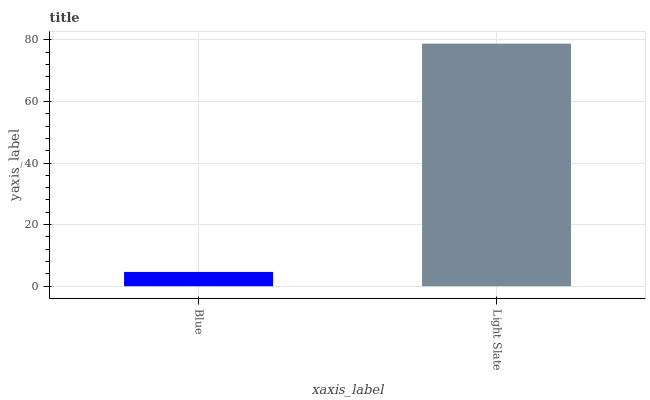Is Light Slate the minimum?
Answer yes or no. No. Is Light Slate greater than Blue?
Answer yes or no. Yes. Is Blue less than Light Slate?
Answer yes or no. Yes. Is Blue greater than Light Slate?
Answer yes or no. No. Is Light Slate less than Blue?
Answer yes or no. No. Is Light Slate the high median?
Answer yes or no. Yes. Is Blue the low median?
Answer yes or no. Yes. Is Blue the high median?
Answer yes or no. No. Is Light Slate the low median?
Answer yes or no. No. 